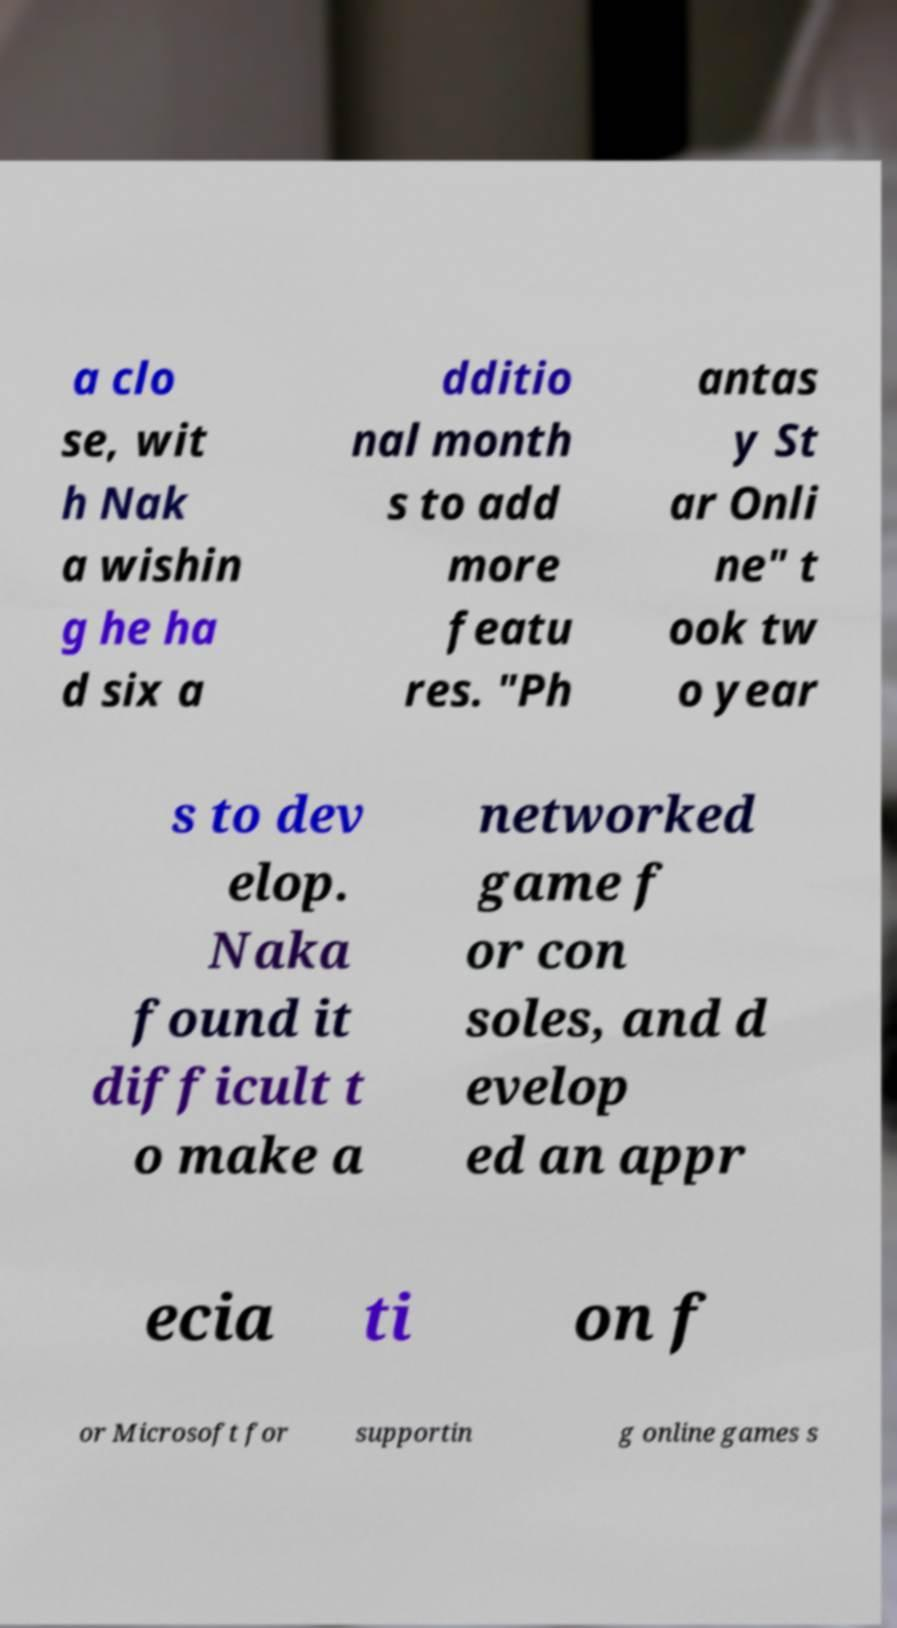I need the written content from this picture converted into text. Can you do that? a clo se, wit h Nak a wishin g he ha d six a dditio nal month s to add more featu res. "Ph antas y St ar Onli ne" t ook tw o year s to dev elop. Naka found it difficult t o make a networked game f or con soles, and d evelop ed an appr ecia ti on f or Microsoft for supportin g online games s 